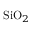<formula> <loc_0><loc_0><loc_500><loc_500>S i O _ { 2 }</formula> 